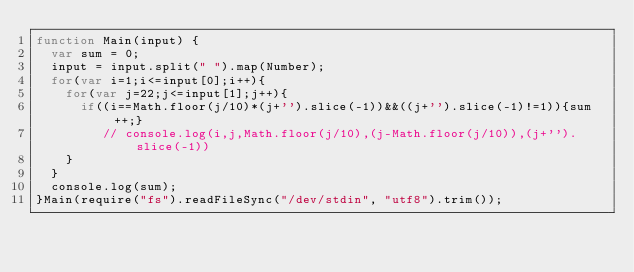<code> <loc_0><loc_0><loc_500><loc_500><_JavaScript_>function Main(input) {
	var sum = 0;
	input = input.split(" ").map(Number);
	for(var i=1;i<=input[0];i++){
		for(var j=22;j<=input[1];j++){
			if((i==Math.floor(j/10)*(j+'').slice(-1))&&((j+'').slice(-1)!=1)){sum++;}
         // console.log(i,j,Math.floor(j/10),(j-Math.floor(j/10)),(j+'').slice(-1))
		}
	}
	console.log(sum);
}Main(require("fs").readFileSync("/dev/stdin", "utf8").trim());</code> 